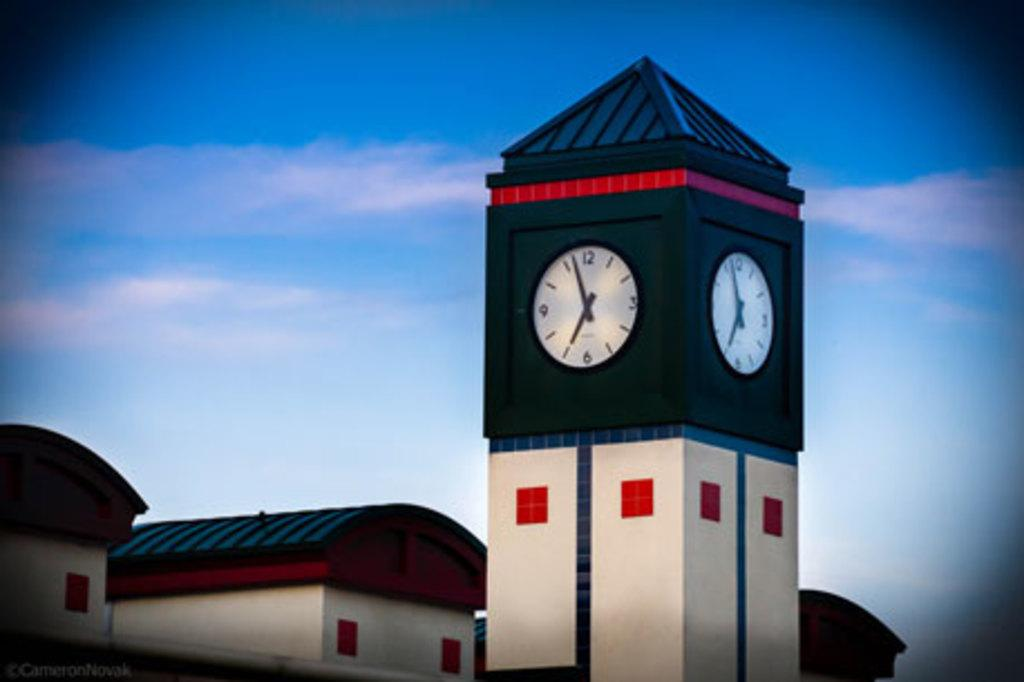What type of structures can be seen in the image? There are houses and a clock tower in the image. Where is the clock tower located in relation to the houses? The clock tower is in the image, but its exact location relative to the houses is not specified. What can be seen in the background of the image? The sky is visible in the background of the image. What is the condition of the sky in the image? Clouds are present in the sky. What type of bead is being used by the judge in the image? There is no judge or bead present in the image. What type of cub is visible in the image? There is no cub present in the image. 